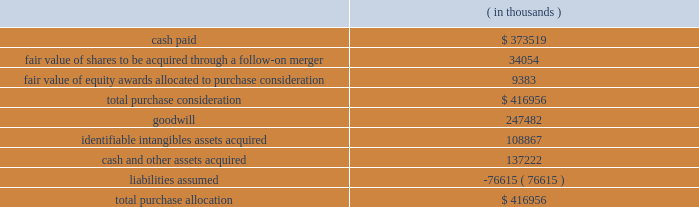Synopsys , inc .
Notes to consolidated financial statements 2014continued the aggregate purchase price consideration was approximately us$ 417.0 million .
As of october 31 , 2012 , the total purchase consideration and the preliminary purchase price allocation were as follows: .
Goodwill of $ 247.5 million , which is generally not deductible for tax purposes , primarily resulted from the company 2019s expectation of sales growth and cost synergies from the integration of springsoft 2019s technology and operations with the company 2019s technology and operations .
Identifiable intangible assets , consisting primarily of technology , customer relationships , backlog and trademarks , were valued using the income method , and are being amortized over three to eight years .
Acquisition-related costs directly attributable to the business combination were $ 6.6 million for fiscal 2012 and were expensed as incurred in the consolidated statements of operations .
These costs consisted primarily of employee separation costs and professional services .
Fair value of equity awards : pursuant to the merger agreement , the company assumed all the unvested outstanding stock options of springsoft upon the completion of the merger and the vested options were exchanged for cash in the merger .
On october 1 , 2012 , the date of the completion of the tender offer , the fair value of the awards to be assumed and exchanged was $ 9.9 million , calculated using the black-scholes option pricing model .
The black-scholes option-pricing model incorporates various subjective assumptions including expected volatility , expected term and risk-free interest rates .
The expected volatility was estimated by a combination of implied and historical stock price volatility of the options .
Non-controlling interest : non-controlling interest represents the fair value of the 8.4% ( 8.4 % ) of outstanding springsoft shares that were not acquired during the tender offer process completed on october 1 , 2012 and the fair value of the option awards that were to be assumed or exchanged for cash upon the follow-on merger .
The fair value of the non-controlling interest included as part of the aggregate purchase consideration was $ 42.8 million and is disclosed as a separate line in the october 31 , 2012 consolidated statements of stockholders 2019 equity .
During the period between the completion of the tender offer and the end of the company 2019s fiscal year on october 31 , 2012 , the non-controlling interest was adjusted by $ 0.5 million to reflect the non-controlling interest 2019s share of the operating loss of springsoft in that period .
As the amount is not significant , it has been included as part of other income ( expense ) , net , in the consolidated statements of operations. .
What percentage of the total purchase consideration is comprised of goodwill and identifiable intangibles assets acquired? 
Rationale: this figure give the percentage paid for soft assets . those that are hard to value .
Computations: ((247482 + 108867) / 416956)
Answer: 0.85464. 